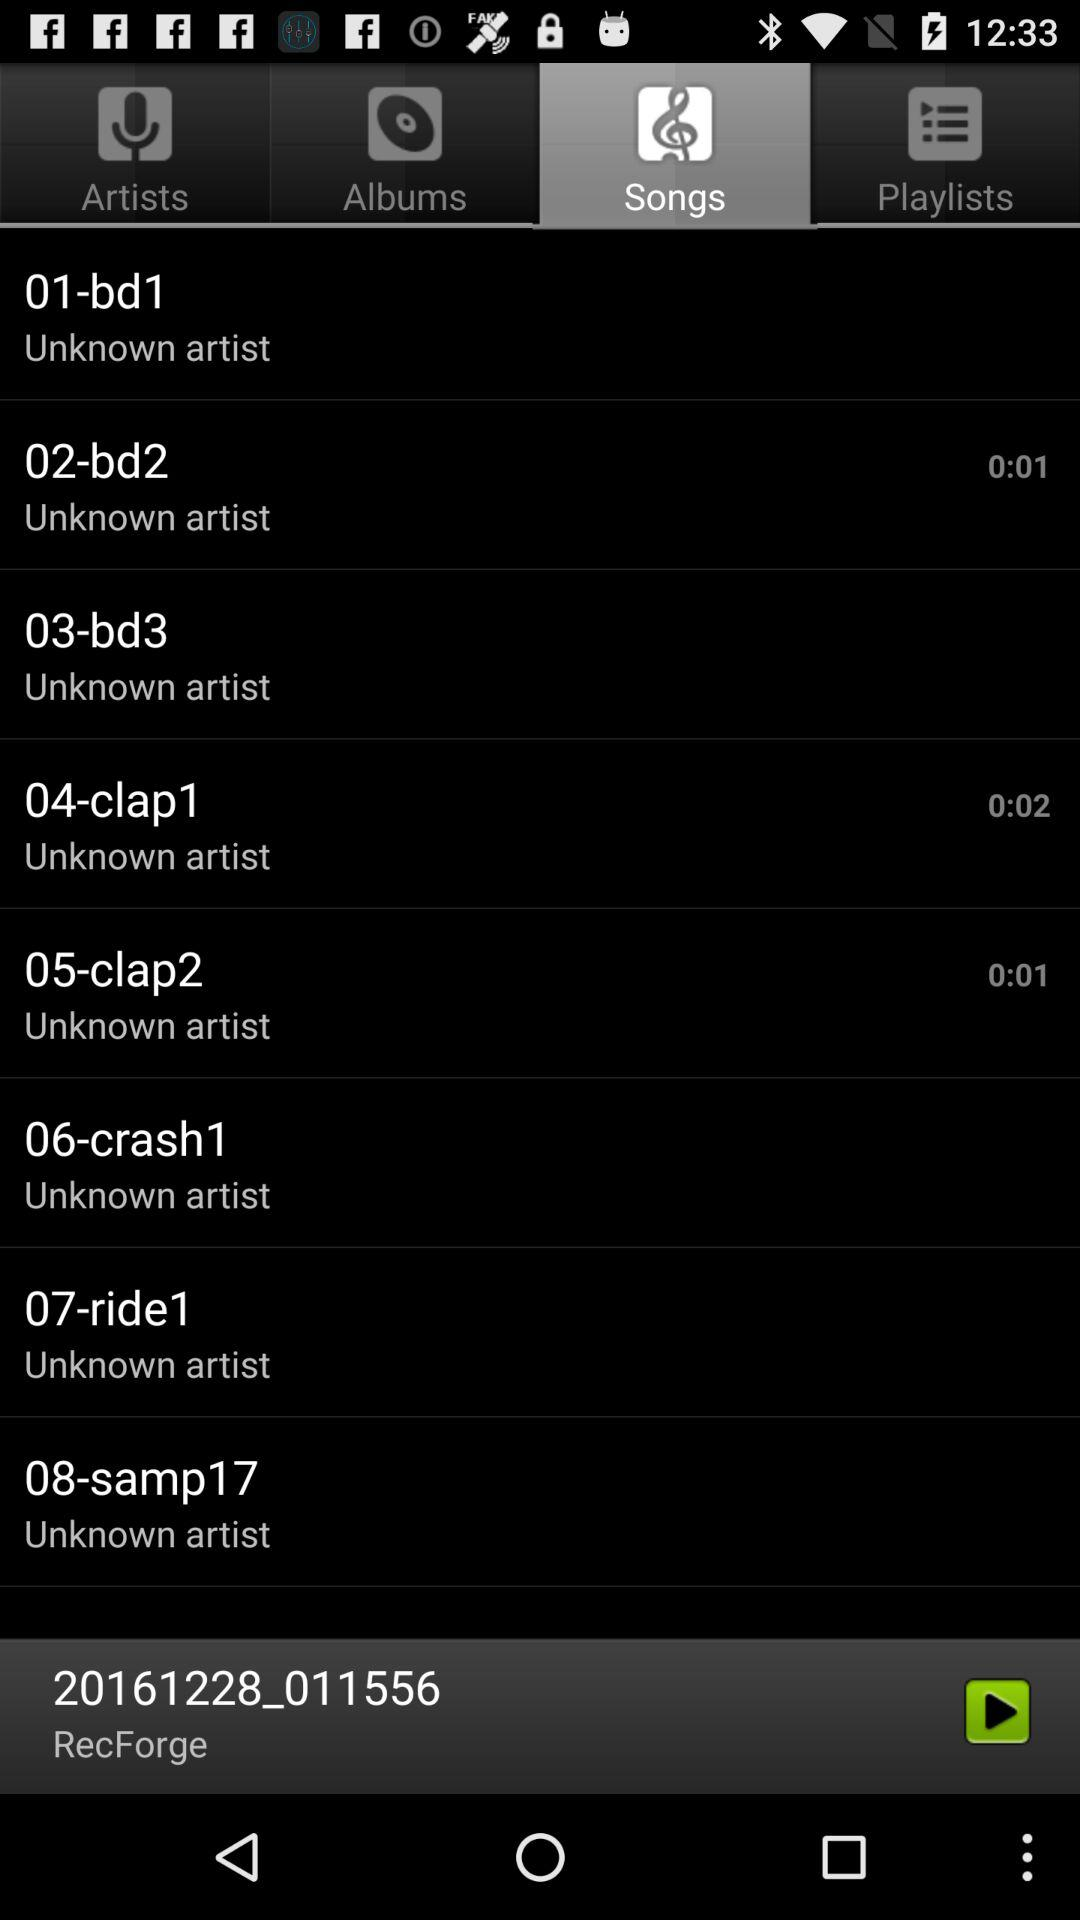Who is the artist of the song "crash1"? The artist is unknown. 